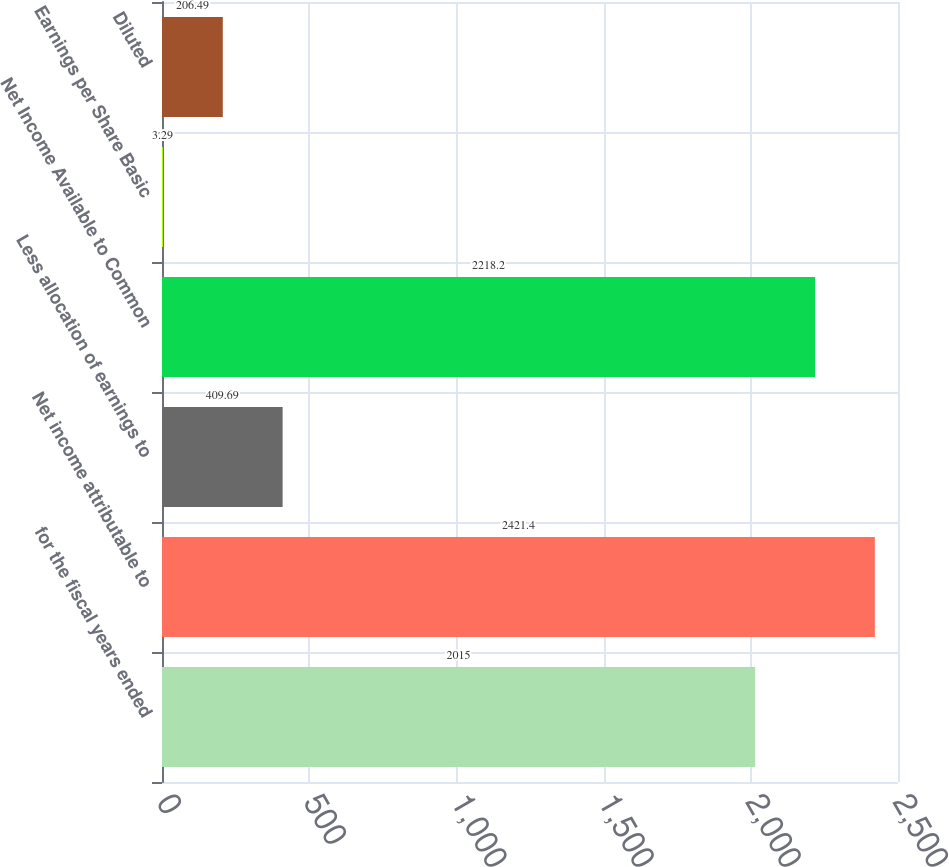<chart> <loc_0><loc_0><loc_500><loc_500><bar_chart><fcel>for the fiscal years ended<fcel>Net income attributable to<fcel>Less allocation of earnings to<fcel>Net Income Available to Common<fcel>Earnings per Share Basic<fcel>Diluted<nl><fcel>2015<fcel>2421.4<fcel>409.69<fcel>2218.2<fcel>3.29<fcel>206.49<nl></chart> 